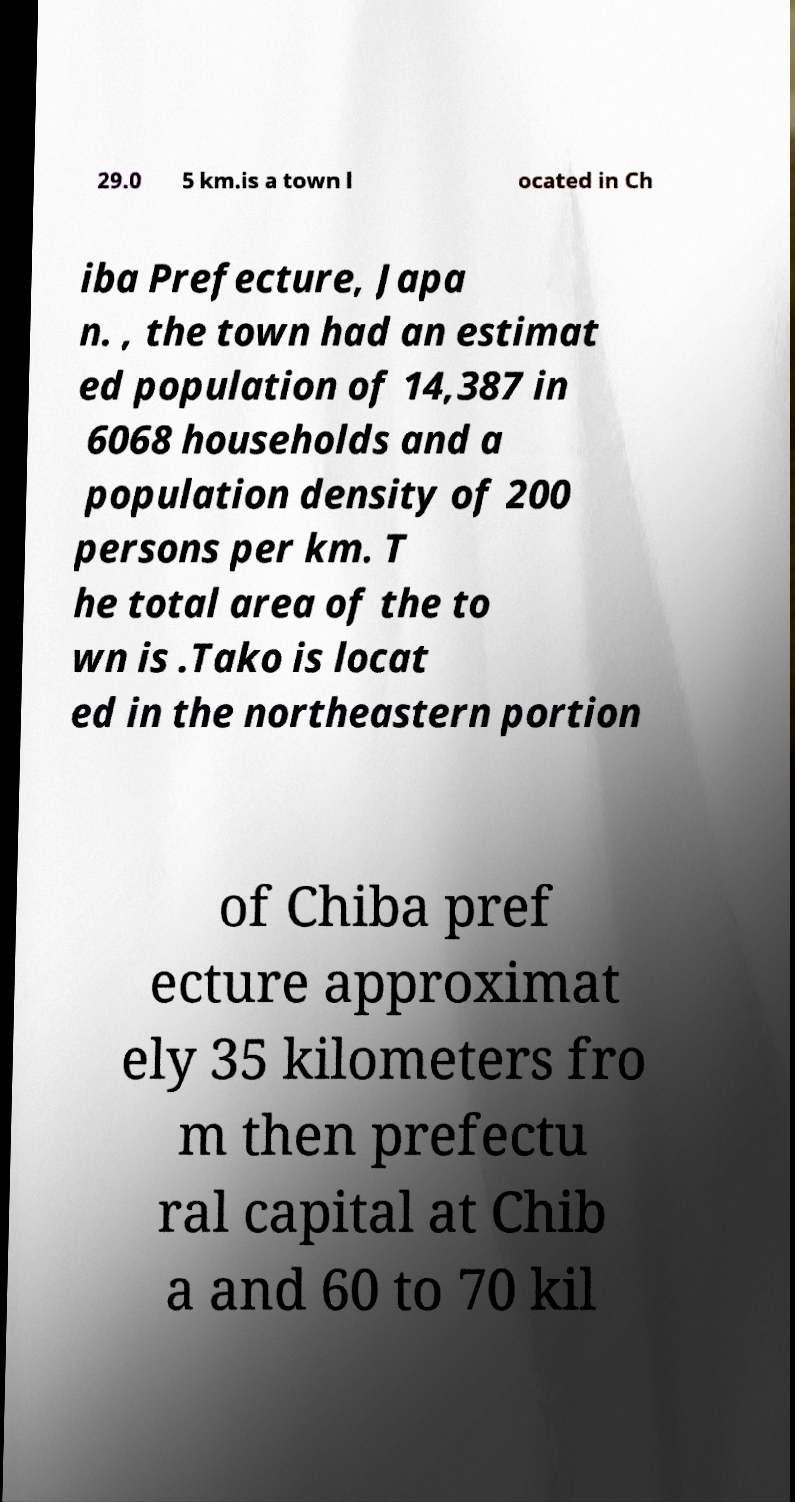Please read and relay the text visible in this image. What does it say? 29.0 5 km.is a town l ocated in Ch iba Prefecture, Japa n. , the town had an estimat ed population of 14,387 in 6068 households and a population density of 200 persons per km. T he total area of the to wn is .Tako is locat ed in the northeastern portion of Chiba pref ecture approximat ely 35 kilometers fro m then prefectu ral capital at Chib a and 60 to 70 kil 